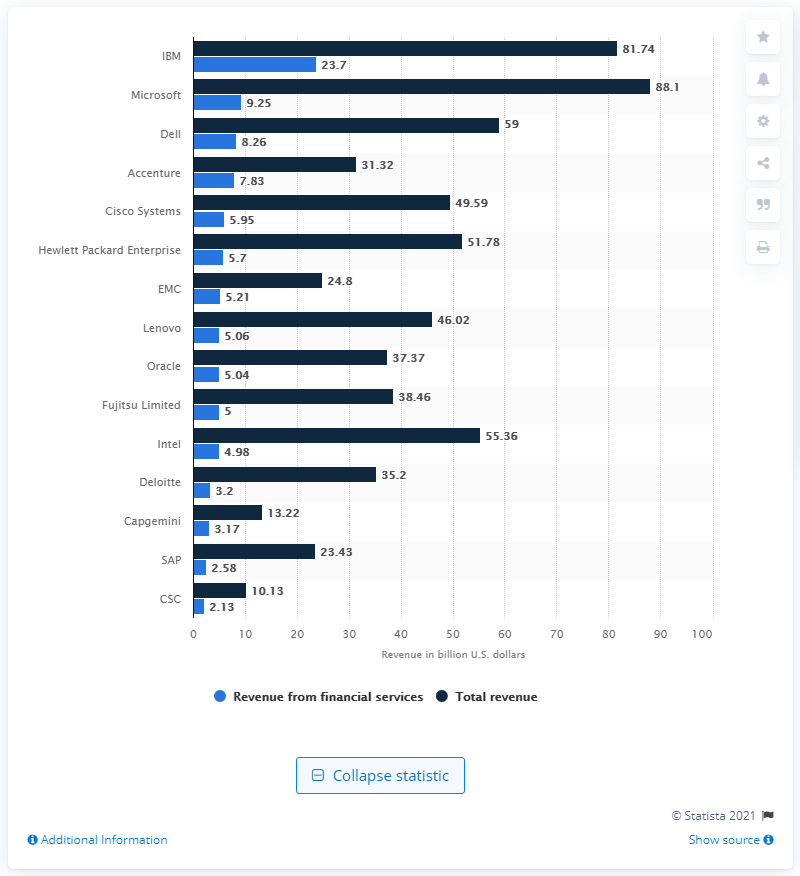Identify some key points in this picture. In 2016, IBM's revenue from financial services was 23.7 billion dollars. 